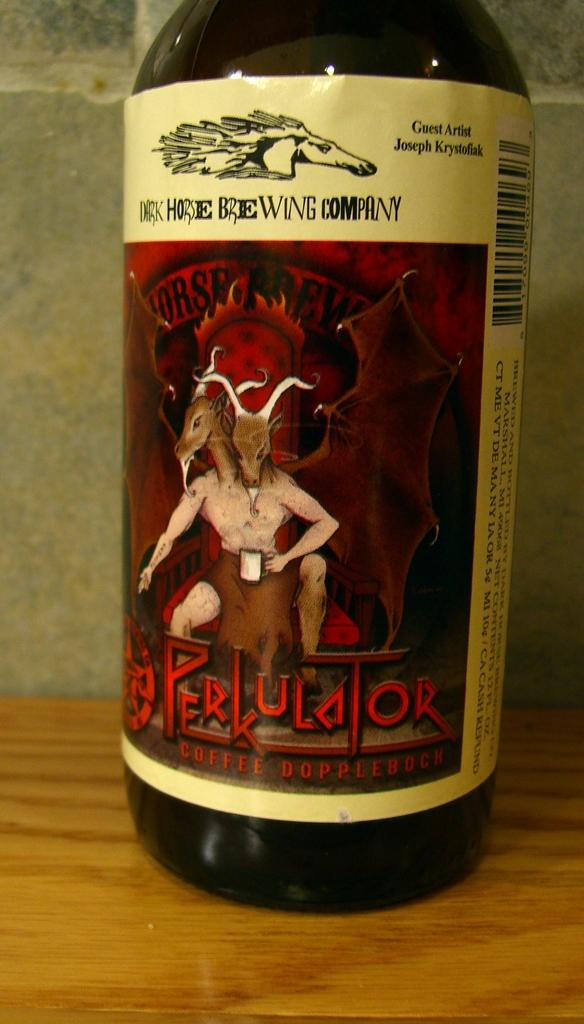<image>
Present a compact description of the photo's key features. A bottle of Perkulator with a scary two headed demon on the label. 